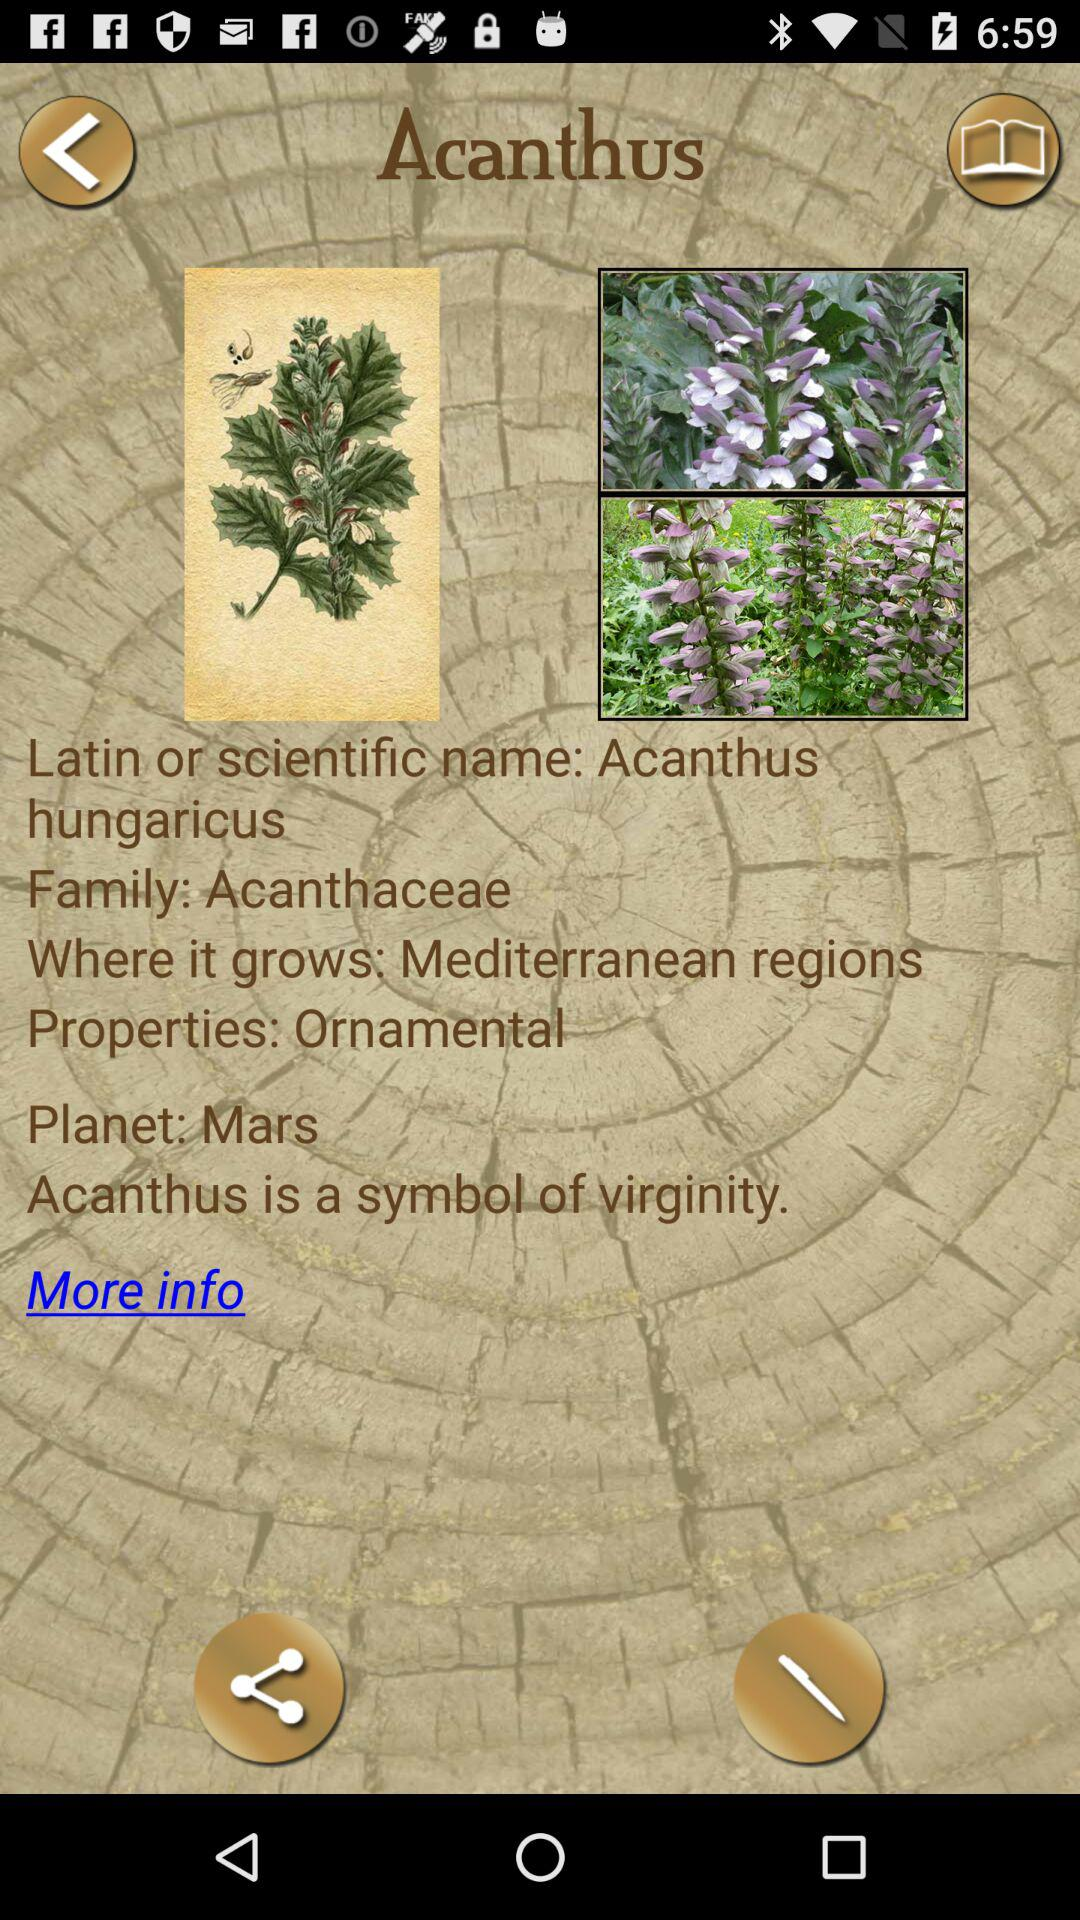What is the planet of the Acanthus? The planet of the Acanthus is Mars. 